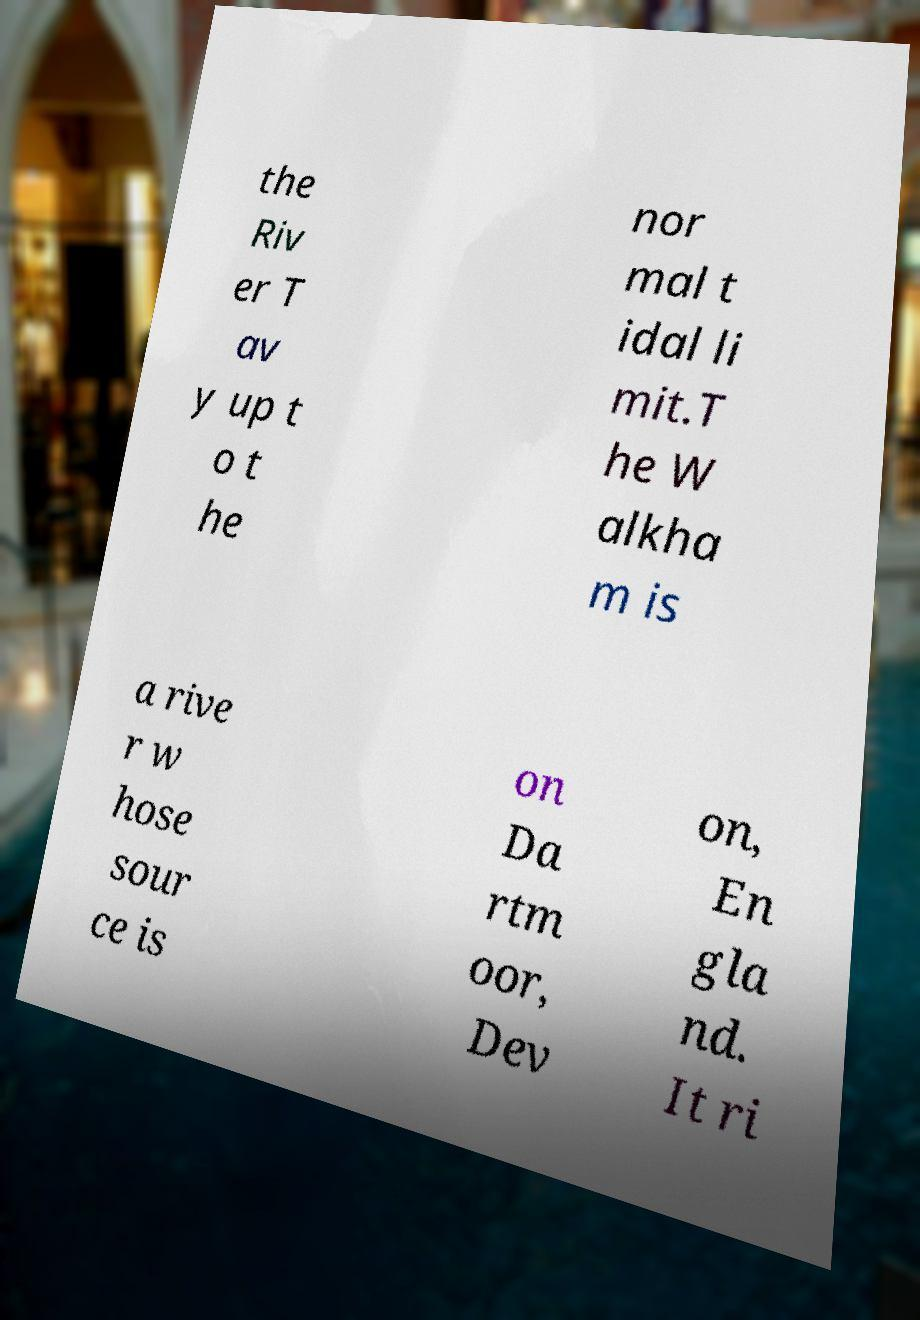Can you read and provide the text displayed in the image?This photo seems to have some interesting text. Can you extract and type it out for me? the Riv er T av y up t o t he nor mal t idal li mit.T he W alkha m is a rive r w hose sour ce is on Da rtm oor, Dev on, En gla nd. It ri 